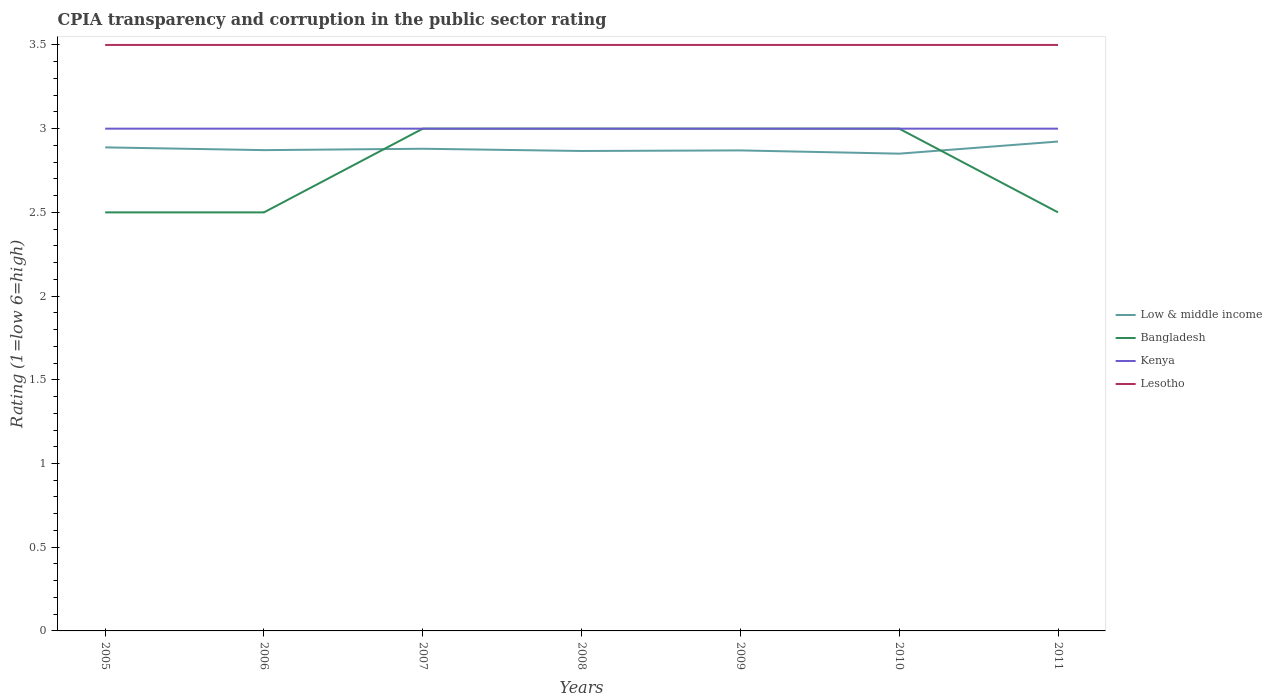How many different coloured lines are there?
Your answer should be very brief. 4. Is the number of lines equal to the number of legend labels?
Keep it short and to the point. Yes. Across all years, what is the maximum CPIA rating in Kenya?
Keep it short and to the point. 3. In which year was the CPIA rating in Bangladesh maximum?
Offer a very short reply. 2005. What is the difference between the highest and the second highest CPIA rating in Lesotho?
Offer a terse response. 0. What is the difference between the highest and the lowest CPIA rating in Lesotho?
Make the answer very short. 0. Is the CPIA rating in Kenya strictly greater than the CPIA rating in Bangladesh over the years?
Your response must be concise. No. Are the values on the major ticks of Y-axis written in scientific E-notation?
Offer a terse response. No. Does the graph contain any zero values?
Keep it short and to the point. No. How many legend labels are there?
Give a very brief answer. 4. How are the legend labels stacked?
Provide a short and direct response. Vertical. What is the title of the graph?
Your response must be concise. CPIA transparency and corruption in the public sector rating. Does "Mauritania" appear as one of the legend labels in the graph?
Ensure brevity in your answer.  No. What is the label or title of the X-axis?
Your response must be concise. Years. What is the label or title of the Y-axis?
Your answer should be compact. Rating (1=low 6=high). What is the Rating (1=low 6=high) in Low & middle income in 2005?
Ensure brevity in your answer.  2.89. What is the Rating (1=low 6=high) of Bangladesh in 2005?
Ensure brevity in your answer.  2.5. What is the Rating (1=low 6=high) of Lesotho in 2005?
Your response must be concise. 3.5. What is the Rating (1=low 6=high) of Low & middle income in 2006?
Keep it short and to the point. 2.87. What is the Rating (1=low 6=high) of Bangladesh in 2006?
Ensure brevity in your answer.  2.5. What is the Rating (1=low 6=high) in Kenya in 2006?
Offer a terse response. 3. What is the Rating (1=low 6=high) of Lesotho in 2006?
Offer a terse response. 3.5. What is the Rating (1=low 6=high) in Low & middle income in 2007?
Make the answer very short. 2.88. What is the Rating (1=low 6=high) in Bangladesh in 2007?
Your response must be concise. 3. What is the Rating (1=low 6=high) of Kenya in 2007?
Provide a succinct answer. 3. What is the Rating (1=low 6=high) in Lesotho in 2007?
Ensure brevity in your answer.  3.5. What is the Rating (1=low 6=high) in Low & middle income in 2008?
Provide a succinct answer. 2.87. What is the Rating (1=low 6=high) of Bangladesh in 2008?
Provide a succinct answer. 3. What is the Rating (1=low 6=high) of Lesotho in 2008?
Ensure brevity in your answer.  3.5. What is the Rating (1=low 6=high) in Low & middle income in 2009?
Your response must be concise. 2.87. What is the Rating (1=low 6=high) of Lesotho in 2009?
Your answer should be compact. 3.5. What is the Rating (1=low 6=high) of Low & middle income in 2010?
Your answer should be compact. 2.85. What is the Rating (1=low 6=high) of Bangladesh in 2010?
Provide a short and direct response. 3. What is the Rating (1=low 6=high) of Kenya in 2010?
Your answer should be very brief. 3. What is the Rating (1=low 6=high) in Lesotho in 2010?
Your answer should be compact. 3.5. What is the Rating (1=low 6=high) of Low & middle income in 2011?
Provide a short and direct response. 2.92. What is the Rating (1=low 6=high) of Kenya in 2011?
Ensure brevity in your answer.  3. What is the Rating (1=low 6=high) of Lesotho in 2011?
Provide a short and direct response. 3.5. Across all years, what is the maximum Rating (1=low 6=high) of Low & middle income?
Provide a short and direct response. 2.92. Across all years, what is the maximum Rating (1=low 6=high) in Lesotho?
Provide a succinct answer. 3.5. Across all years, what is the minimum Rating (1=low 6=high) of Low & middle income?
Your response must be concise. 2.85. Across all years, what is the minimum Rating (1=low 6=high) of Kenya?
Your answer should be very brief. 3. What is the total Rating (1=low 6=high) in Low & middle income in the graph?
Your answer should be very brief. 20.15. What is the total Rating (1=low 6=high) of Bangladesh in the graph?
Your answer should be compact. 19.5. What is the total Rating (1=low 6=high) in Kenya in the graph?
Ensure brevity in your answer.  21. What is the difference between the Rating (1=low 6=high) of Low & middle income in 2005 and that in 2006?
Provide a short and direct response. 0.02. What is the difference between the Rating (1=low 6=high) in Kenya in 2005 and that in 2006?
Provide a short and direct response. 0. What is the difference between the Rating (1=low 6=high) of Lesotho in 2005 and that in 2006?
Provide a short and direct response. 0. What is the difference between the Rating (1=low 6=high) of Low & middle income in 2005 and that in 2007?
Your answer should be very brief. 0.01. What is the difference between the Rating (1=low 6=high) of Low & middle income in 2005 and that in 2008?
Ensure brevity in your answer.  0.02. What is the difference between the Rating (1=low 6=high) of Bangladesh in 2005 and that in 2008?
Offer a very short reply. -0.5. What is the difference between the Rating (1=low 6=high) of Kenya in 2005 and that in 2008?
Give a very brief answer. 0. What is the difference between the Rating (1=low 6=high) in Lesotho in 2005 and that in 2008?
Provide a short and direct response. 0. What is the difference between the Rating (1=low 6=high) of Low & middle income in 2005 and that in 2009?
Provide a short and direct response. 0.02. What is the difference between the Rating (1=low 6=high) in Bangladesh in 2005 and that in 2009?
Offer a very short reply. -0.5. What is the difference between the Rating (1=low 6=high) of Lesotho in 2005 and that in 2009?
Your answer should be compact. 0. What is the difference between the Rating (1=low 6=high) of Low & middle income in 2005 and that in 2010?
Make the answer very short. 0.04. What is the difference between the Rating (1=low 6=high) in Bangladesh in 2005 and that in 2010?
Keep it short and to the point. -0.5. What is the difference between the Rating (1=low 6=high) of Kenya in 2005 and that in 2010?
Make the answer very short. 0. What is the difference between the Rating (1=low 6=high) of Low & middle income in 2005 and that in 2011?
Your answer should be very brief. -0.03. What is the difference between the Rating (1=low 6=high) of Bangladesh in 2005 and that in 2011?
Keep it short and to the point. 0. What is the difference between the Rating (1=low 6=high) in Lesotho in 2005 and that in 2011?
Your response must be concise. 0. What is the difference between the Rating (1=low 6=high) of Low & middle income in 2006 and that in 2007?
Make the answer very short. -0.01. What is the difference between the Rating (1=low 6=high) of Bangladesh in 2006 and that in 2007?
Offer a very short reply. -0.5. What is the difference between the Rating (1=low 6=high) in Lesotho in 2006 and that in 2007?
Keep it short and to the point. 0. What is the difference between the Rating (1=low 6=high) in Low & middle income in 2006 and that in 2008?
Your response must be concise. 0.01. What is the difference between the Rating (1=low 6=high) of Bangladesh in 2006 and that in 2008?
Provide a short and direct response. -0.5. What is the difference between the Rating (1=low 6=high) of Kenya in 2006 and that in 2008?
Provide a succinct answer. 0. What is the difference between the Rating (1=low 6=high) in Low & middle income in 2006 and that in 2009?
Offer a terse response. 0. What is the difference between the Rating (1=low 6=high) of Bangladesh in 2006 and that in 2009?
Your response must be concise. -0.5. What is the difference between the Rating (1=low 6=high) of Lesotho in 2006 and that in 2009?
Ensure brevity in your answer.  0. What is the difference between the Rating (1=low 6=high) in Low & middle income in 2006 and that in 2010?
Provide a short and direct response. 0.02. What is the difference between the Rating (1=low 6=high) of Kenya in 2006 and that in 2010?
Offer a terse response. 0. What is the difference between the Rating (1=low 6=high) in Low & middle income in 2006 and that in 2011?
Your answer should be compact. -0.05. What is the difference between the Rating (1=low 6=high) in Low & middle income in 2007 and that in 2008?
Provide a succinct answer. 0.01. What is the difference between the Rating (1=low 6=high) of Kenya in 2007 and that in 2008?
Offer a very short reply. 0. What is the difference between the Rating (1=low 6=high) of Lesotho in 2007 and that in 2008?
Your answer should be very brief. 0. What is the difference between the Rating (1=low 6=high) in Low & middle income in 2007 and that in 2009?
Ensure brevity in your answer.  0.01. What is the difference between the Rating (1=low 6=high) of Bangladesh in 2007 and that in 2009?
Your response must be concise. 0. What is the difference between the Rating (1=low 6=high) in Kenya in 2007 and that in 2009?
Provide a succinct answer. 0. What is the difference between the Rating (1=low 6=high) in Low & middle income in 2007 and that in 2010?
Provide a succinct answer. 0.03. What is the difference between the Rating (1=low 6=high) of Bangladesh in 2007 and that in 2010?
Give a very brief answer. 0. What is the difference between the Rating (1=low 6=high) in Lesotho in 2007 and that in 2010?
Your response must be concise. 0. What is the difference between the Rating (1=low 6=high) in Low & middle income in 2007 and that in 2011?
Ensure brevity in your answer.  -0.04. What is the difference between the Rating (1=low 6=high) of Kenya in 2007 and that in 2011?
Your answer should be very brief. 0. What is the difference between the Rating (1=low 6=high) of Low & middle income in 2008 and that in 2009?
Provide a succinct answer. -0. What is the difference between the Rating (1=low 6=high) of Bangladesh in 2008 and that in 2009?
Your answer should be very brief. 0. What is the difference between the Rating (1=low 6=high) of Kenya in 2008 and that in 2009?
Provide a succinct answer. 0. What is the difference between the Rating (1=low 6=high) in Lesotho in 2008 and that in 2009?
Keep it short and to the point. 0. What is the difference between the Rating (1=low 6=high) of Low & middle income in 2008 and that in 2010?
Provide a short and direct response. 0.02. What is the difference between the Rating (1=low 6=high) of Lesotho in 2008 and that in 2010?
Give a very brief answer. 0. What is the difference between the Rating (1=low 6=high) in Low & middle income in 2008 and that in 2011?
Provide a succinct answer. -0.06. What is the difference between the Rating (1=low 6=high) of Low & middle income in 2009 and that in 2010?
Ensure brevity in your answer.  0.02. What is the difference between the Rating (1=low 6=high) in Bangladesh in 2009 and that in 2010?
Offer a very short reply. 0. What is the difference between the Rating (1=low 6=high) in Low & middle income in 2009 and that in 2011?
Your answer should be very brief. -0.05. What is the difference between the Rating (1=low 6=high) in Bangladesh in 2009 and that in 2011?
Your response must be concise. 0.5. What is the difference between the Rating (1=low 6=high) of Lesotho in 2009 and that in 2011?
Your response must be concise. 0. What is the difference between the Rating (1=low 6=high) in Low & middle income in 2010 and that in 2011?
Ensure brevity in your answer.  -0.07. What is the difference between the Rating (1=low 6=high) of Bangladesh in 2010 and that in 2011?
Ensure brevity in your answer.  0.5. What is the difference between the Rating (1=low 6=high) in Low & middle income in 2005 and the Rating (1=low 6=high) in Bangladesh in 2006?
Give a very brief answer. 0.39. What is the difference between the Rating (1=low 6=high) of Low & middle income in 2005 and the Rating (1=low 6=high) of Kenya in 2006?
Give a very brief answer. -0.11. What is the difference between the Rating (1=low 6=high) of Low & middle income in 2005 and the Rating (1=low 6=high) of Lesotho in 2006?
Provide a short and direct response. -0.61. What is the difference between the Rating (1=low 6=high) in Bangladesh in 2005 and the Rating (1=low 6=high) in Lesotho in 2006?
Your response must be concise. -1. What is the difference between the Rating (1=low 6=high) of Low & middle income in 2005 and the Rating (1=low 6=high) of Bangladesh in 2007?
Make the answer very short. -0.11. What is the difference between the Rating (1=low 6=high) of Low & middle income in 2005 and the Rating (1=low 6=high) of Kenya in 2007?
Provide a succinct answer. -0.11. What is the difference between the Rating (1=low 6=high) of Low & middle income in 2005 and the Rating (1=low 6=high) of Lesotho in 2007?
Make the answer very short. -0.61. What is the difference between the Rating (1=low 6=high) in Bangladesh in 2005 and the Rating (1=low 6=high) in Lesotho in 2007?
Ensure brevity in your answer.  -1. What is the difference between the Rating (1=low 6=high) in Low & middle income in 2005 and the Rating (1=low 6=high) in Bangladesh in 2008?
Keep it short and to the point. -0.11. What is the difference between the Rating (1=low 6=high) of Low & middle income in 2005 and the Rating (1=low 6=high) of Kenya in 2008?
Your answer should be very brief. -0.11. What is the difference between the Rating (1=low 6=high) of Low & middle income in 2005 and the Rating (1=low 6=high) of Lesotho in 2008?
Ensure brevity in your answer.  -0.61. What is the difference between the Rating (1=low 6=high) in Kenya in 2005 and the Rating (1=low 6=high) in Lesotho in 2008?
Ensure brevity in your answer.  -0.5. What is the difference between the Rating (1=low 6=high) in Low & middle income in 2005 and the Rating (1=low 6=high) in Bangladesh in 2009?
Provide a short and direct response. -0.11. What is the difference between the Rating (1=low 6=high) of Low & middle income in 2005 and the Rating (1=low 6=high) of Kenya in 2009?
Provide a succinct answer. -0.11. What is the difference between the Rating (1=low 6=high) of Low & middle income in 2005 and the Rating (1=low 6=high) of Lesotho in 2009?
Provide a short and direct response. -0.61. What is the difference between the Rating (1=low 6=high) of Bangladesh in 2005 and the Rating (1=low 6=high) of Kenya in 2009?
Provide a short and direct response. -0.5. What is the difference between the Rating (1=low 6=high) in Bangladesh in 2005 and the Rating (1=low 6=high) in Lesotho in 2009?
Your answer should be very brief. -1. What is the difference between the Rating (1=low 6=high) in Low & middle income in 2005 and the Rating (1=low 6=high) in Bangladesh in 2010?
Provide a succinct answer. -0.11. What is the difference between the Rating (1=low 6=high) in Low & middle income in 2005 and the Rating (1=low 6=high) in Kenya in 2010?
Provide a short and direct response. -0.11. What is the difference between the Rating (1=low 6=high) of Low & middle income in 2005 and the Rating (1=low 6=high) of Lesotho in 2010?
Your answer should be compact. -0.61. What is the difference between the Rating (1=low 6=high) in Bangladesh in 2005 and the Rating (1=low 6=high) in Kenya in 2010?
Your response must be concise. -0.5. What is the difference between the Rating (1=low 6=high) of Low & middle income in 2005 and the Rating (1=low 6=high) of Bangladesh in 2011?
Offer a terse response. 0.39. What is the difference between the Rating (1=low 6=high) in Low & middle income in 2005 and the Rating (1=low 6=high) in Kenya in 2011?
Ensure brevity in your answer.  -0.11. What is the difference between the Rating (1=low 6=high) in Low & middle income in 2005 and the Rating (1=low 6=high) in Lesotho in 2011?
Provide a short and direct response. -0.61. What is the difference between the Rating (1=low 6=high) of Bangladesh in 2005 and the Rating (1=low 6=high) of Kenya in 2011?
Offer a very short reply. -0.5. What is the difference between the Rating (1=low 6=high) of Bangladesh in 2005 and the Rating (1=low 6=high) of Lesotho in 2011?
Ensure brevity in your answer.  -1. What is the difference between the Rating (1=low 6=high) of Low & middle income in 2006 and the Rating (1=low 6=high) of Bangladesh in 2007?
Your answer should be compact. -0.13. What is the difference between the Rating (1=low 6=high) in Low & middle income in 2006 and the Rating (1=low 6=high) in Kenya in 2007?
Offer a very short reply. -0.13. What is the difference between the Rating (1=low 6=high) in Low & middle income in 2006 and the Rating (1=low 6=high) in Lesotho in 2007?
Provide a short and direct response. -0.63. What is the difference between the Rating (1=low 6=high) in Bangladesh in 2006 and the Rating (1=low 6=high) in Kenya in 2007?
Offer a terse response. -0.5. What is the difference between the Rating (1=low 6=high) in Low & middle income in 2006 and the Rating (1=low 6=high) in Bangladesh in 2008?
Your answer should be very brief. -0.13. What is the difference between the Rating (1=low 6=high) in Low & middle income in 2006 and the Rating (1=low 6=high) in Kenya in 2008?
Provide a succinct answer. -0.13. What is the difference between the Rating (1=low 6=high) of Low & middle income in 2006 and the Rating (1=low 6=high) of Lesotho in 2008?
Give a very brief answer. -0.63. What is the difference between the Rating (1=low 6=high) in Low & middle income in 2006 and the Rating (1=low 6=high) in Bangladesh in 2009?
Make the answer very short. -0.13. What is the difference between the Rating (1=low 6=high) of Low & middle income in 2006 and the Rating (1=low 6=high) of Kenya in 2009?
Give a very brief answer. -0.13. What is the difference between the Rating (1=low 6=high) of Low & middle income in 2006 and the Rating (1=low 6=high) of Lesotho in 2009?
Provide a succinct answer. -0.63. What is the difference between the Rating (1=low 6=high) of Bangladesh in 2006 and the Rating (1=low 6=high) of Kenya in 2009?
Offer a very short reply. -0.5. What is the difference between the Rating (1=low 6=high) in Bangladesh in 2006 and the Rating (1=low 6=high) in Lesotho in 2009?
Offer a very short reply. -1. What is the difference between the Rating (1=low 6=high) in Kenya in 2006 and the Rating (1=low 6=high) in Lesotho in 2009?
Your answer should be very brief. -0.5. What is the difference between the Rating (1=low 6=high) of Low & middle income in 2006 and the Rating (1=low 6=high) of Bangladesh in 2010?
Your answer should be very brief. -0.13. What is the difference between the Rating (1=low 6=high) of Low & middle income in 2006 and the Rating (1=low 6=high) of Kenya in 2010?
Provide a short and direct response. -0.13. What is the difference between the Rating (1=low 6=high) of Low & middle income in 2006 and the Rating (1=low 6=high) of Lesotho in 2010?
Make the answer very short. -0.63. What is the difference between the Rating (1=low 6=high) in Bangladesh in 2006 and the Rating (1=low 6=high) in Lesotho in 2010?
Provide a short and direct response. -1. What is the difference between the Rating (1=low 6=high) in Kenya in 2006 and the Rating (1=low 6=high) in Lesotho in 2010?
Offer a very short reply. -0.5. What is the difference between the Rating (1=low 6=high) of Low & middle income in 2006 and the Rating (1=low 6=high) of Bangladesh in 2011?
Keep it short and to the point. 0.37. What is the difference between the Rating (1=low 6=high) of Low & middle income in 2006 and the Rating (1=low 6=high) of Kenya in 2011?
Ensure brevity in your answer.  -0.13. What is the difference between the Rating (1=low 6=high) of Low & middle income in 2006 and the Rating (1=low 6=high) of Lesotho in 2011?
Provide a short and direct response. -0.63. What is the difference between the Rating (1=low 6=high) in Kenya in 2006 and the Rating (1=low 6=high) in Lesotho in 2011?
Give a very brief answer. -0.5. What is the difference between the Rating (1=low 6=high) of Low & middle income in 2007 and the Rating (1=low 6=high) of Bangladesh in 2008?
Provide a short and direct response. -0.12. What is the difference between the Rating (1=low 6=high) in Low & middle income in 2007 and the Rating (1=low 6=high) in Kenya in 2008?
Offer a very short reply. -0.12. What is the difference between the Rating (1=low 6=high) of Low & middle income in 2007 and the Rating (1=low 6=high) of Lesotho in 2008?
Make the answer very short. -0.62. What is the difference between the Rating (1=low 6=high) of Bangladesh in 2007 and the Rating (1=low 6=high) of Kenya in 2008?
Provide a succinct answer. 0. What is the difference between the Rating (1=low 6=high) in Kenya in 2007 and the Rating (1=low 6=high) in Lesotho in 2008?
Offer a terse response. -0.5. What is the difference between the Rating (1=low 6=high) in Low & middle income in 2007 and the Rating (1=low 6=high) in Bangladesh in 2009?
Your response must be concise. -0.12. What is the difference between the Rating (1=low 6=high) of Low & middle income in 2007 and the Rating (1=low 6=high) of Kenya in 2009?
Keep it short and to the point. -0.12. What is the difference between the Rating (1=low 6=high) of Low & middle income in 2007 and the Rating (1=low 6=high) of Lesotho in 2009?
Offer a very short reply. -0.62. What is the difference between the Rating (1=low 6=high) of Bangladesh in 2007 and the Rating (1=low 6=high) of Kenya in 2009?
Make the answer very short. 0. What is the difference between the Rating (1=low 6=high) in Bangladesh in 2007 and the Rating (1=low 6=high) in Lesotho in 2009?
Offer a very short reply. -0.5. What is the difference between the Rating (1=low 6=high) in Kenya in 2007 and the Rating (1=low 6=high) in Lesotho in 2009?
Your response must be concise. -0.5. What is the difference between the Rating (1=low 6=high) of Low & middle income in 2007 and the Rating (1=low 6=high) of Bangladesh in 2010?
Give a very brief answer. -0.12. What is the difference between the Rating (1=low 6=high) of Low & middle income in 2007 and the Rating (1=low 6=high) of Kenya in 2010?
Keep it short and to the point. -0.12. What is the difference between the Rating (1=low 6=high) of Low & middle income in 2007 and the Rating (1=low 6=high) of Lesotho in 2010?
Your response must be concise. -0.62. What is the difference between the Rating (1=low 6=high) of Bangladesh in 2007 and the Rating (1=low 6=high) of Kenya in 2010?
Keep it short and to the point. 0. What is the difference between the Rating (1=low 6=high) of Kenya in 2007 and the Rating (1=low 6=high) of Lesotho in 2010?
Your answer should be very brief. -0.5. What is the difference between the Rating (1=low 6=high) in Low & middle income in 2007 and the Rating (1=low 6=high) in Bangladesh in 2011?
Give a very brief answer. 0.38. What is the difference between the Rating (1=low 6=high) of Low & middle income in 2007 and the Rating (1=low 6=high) of Kenya in 2011?
Offer a terse response. -0.12. What is the difference between the Rating (1=low 6=high) in Low & middle income in 2007 and the Rating (1=low 6=high) in Lesotho in 2011?
Offer a terse response. -0.62. What is the difference between the Rating (1=low 6=high) in Bangladesh in 2007 and the Rating (1=low 6=high) in Kenya in 2011?
Keep it short and to the point. 0. What is the difference between the Rating (1=low 6=high) of Low & middle income in 2008 and the Rating (1=low 6=high) of Bangladesh in 2009?
Make the answer very short. -0.13. What is the difference between the Rating (1=low 6=high) of Low & middle income in 2008 and the Rating (1=low 6=high) of Kenya in 2009?
Offer a terse response. -0.13. What is the difference between the Rating (1=low 6=high) in Low & middle income in 2008 and the Rating (1=low 6=high) in Lesotho in 2009?
Provide a succinct answer. -0.63. What is the difference between the Rating (1=low 6=high) of Bangladesh in 2008 and the Rating (1=low 6=high) of Lesotho in 2009?
Your response must be concise. -0.5. What is the difference between the Rating (1=low 6=high) in Low & middle income in 2008 and the Rating (1=low 6=high) in Bangladesh in 2010?
Your answer should be very brief. -0.13. What is the difference between the Rating (1=low 6=high) of Low & middle income in 2008 and the Rating (1=low 6=high) of Kenya in 2010?
Offer a very short reply. -0.13. What is the difference between the Rating (1=low 6=high) of Low & middle income in 2008 and the Rating (1=low 6=high) of Lesotho in 2010?
Provide a short and direct response. -0.63. What is the difference between the Rating (1=low 6=high) in Bangladesh in 2008 and the Rating (1=low 6=high) in Kenya in 2010?
Provide a succinct answer. 0. What is the difference between the Rating (1=low 6=high) of Kenya in 2008 and the Rating (1=low 6=high) of Lesotho in 2010?
Make the answer very short. -0.5. What is the difference between the Rating (1=low 6=high) in Low & middle income in 2008 and the Rating (1=low 6=high) in Bangladesh in 2011?
Ensure brevity in your answer.  0.37. What is the difference between the Rating (1=low 6=high) in Low & middle income in 2008 and the Rating (1=low 6=high) in Kenya in 2011?
Offer a very short reply. -0.13. What is the difference between the Rating (1=low 6=high) of Low & middle income in 2008 and the Rating (1=low 6=high) of Lesotho in 2011?
Your response must be concise. -0.63. What is the difference between the Rating (1=low 6=high) in Bangladesh in 2008 and the Rating (1=low 6=high) in Kenya in 2011?
Offer a terse response. 0. What is the difference between the Rating (1=low 6=high) in Low & middle income in 2009 and the Rating (1=low 6=high) in Bangladesh in 2010?
Give a very brief answer. -0.13. What is the difference between the Rating (1=low 6=high) of Low & middle income in 2009 and the Rating (1=low 6=high) of Kenya in 2010?
Your answer should be very brief. -0.13. What is the difference between the Rating (1=low 6=high) of Low & middle income in 2009 and the Rating (1=low 6=high) of Lesotho in 2010?
Keep it short and to the point. -0.63. What is the difference between the Rating (1=low 6=high) of Bangladesh in 2009 and the Rating (1=low 6=high) of Kenya in 2010?
Your response must be concise. 0. What is the difference between the Rating (1=low 6=high) of Kenya in 2009 and the Rating (1=low 6=high) of Lesotho in 2010?
Your answer should be very brief. -0.5. What is the difference between the Rating (1=low 6=high) in Low & middle income in 2009 and the Rating (1=low 6=high) in Bangladesh in 2011?
Provide a succinct answer. 0.37. What is the difference between the Rating (1=low 6=high) of Low & middle income in 2009 and the Rating (1=low 6=high) of Kenya in 2011?
Offer a very short reply. -0.13. What is the difference between the Rating (1=low 6=high) of Low & middle income in 2009 and the Rating (1=low 6=high) of Lesotho in 2011?
Your response must be concise. -0.63. What is the difference between the Rating (1=low 6=high) in Bangladesh in 2009 and the Rating (1=low 6=high) in Kenya in 2011?
Your answer should be very brief. 0. What is the difference between the Rating (1=low 6=high) of Kenya in 2009 and the Rating (1=low 6=high) of Lesotho in 2011?
Your response must be concise. -0.5. What is the difference between the Rating (1=low 6=high) of Low & middle income in 2010 and the Rating (1=low 6=high) of Bangladesh in 2011?
Your answer should be very brief. 0.35. What is the difference between the Rating (1=low 6=high) of Low & middle income in 2010 and the Rating (1=low 6=high) of Kenya in 2011?
Give a very brief answer. -0.15. What is the difference between the Rating (1=low 6=high) in Low & middle income in 2010 and the Rating (1=low 6=high) in Lesotho in 2011?
Your answer should be very brief. -0.65. What is the difference between the Rating (1=low 6=high) in Bangladesh in 2010 and the Rating (1=low 6=high) in Kenya in 2011?
Your answer should be compact. 0. What is the difference between the Rating (1=low 6=high) of Bangladesh in 2010 and the Rating (1=low 6=high) of Lesotho in 2011?
Your answer should be very brief. -0.5. What is the difference between the Rating (1=low 6=high) in Kenya in 2010 and the Rating (1=low 6=high) in Lesotho in 2011?
Your answer should be very brief. -0.5. What is the average Rating (1=low 6=high) of Low & middle income per year?
Offer a very short reply. 2.88. What is the average Rating (1=low 6=high) of Bangladesh per year?
Keep it short and to the point. 2.79. In the year 2005, what is the difference between the Rating (1=low 6=high) of Low & middle income and Rating (1=low 6=high) of Bangladesh?
Give a very brief answer. 0.39. In the year 2005, what is the difference between the Rating (1=low 6=high) in Low & middle income and Rating (1=low 6=high) in Kenya?
Keep it short and to the point. -0.11. In the year 2005, what is the difference between the Rating (1=low 6=high) in Low & middle income and Rating (1=low 6=high) in Lesotho?
Keep it short and to the point. -0.61. In the year 2005, what is the difference between the Rating (1=low 6=high) in Kenya and Rating (1=low 6=high) in Lesotho?
Offer a terse response. -0.5. In the year 2006, what is the difference between the Rating (1=low 6=high) in Low & middle income and Rating (1=low 6=high) in Bangladesh?
Provide a short and direct response. 0.37. In the year 2006, what is the difference between the Rating (1=low 6=high) of Low & middle income and Rating (1=low 6=high) of Kenya?
Give a very brief answer. -0.13. In the year 2006, what is the difference between the Rating (1=low 6=high) in Low & middle income and Rating (1=low 6=high) in Lesotho?
Offer a terse response. -0.63. In the year 2006, what is the difference between the Rating (1=low 6=high) in Bangladesh and Rating (1=low 6=high) in Lesotho?
Give a very brief answer. -1. In the year 2006, what is the difference between the Rating (1=low 6=high) of Kenya and Rating (1=low 6=high) of Lesotho?
Your answer should be compact. -0.5. In the year 2007, what is the difference between the Rating (1=low 6=high) in Low & middle income and Rating (1=low 6=high) in Bangladesh?
Provide a succinct answer. -0.12. In the year 2007, what is the difference between the Rating (1=low 6=high) of Low & middle income and Rating (1=low 6=high) of Kenya?
Offer a very short reply. -0.12. In the year 2007, what is the difference between the Rating (1=low 6=high) in Low & middle income and Rating (1=low 6=high) in Lesotho?
Your answer should be very brief. -0.62. In the year 2007, what is the difference between the Rating (1=low 6=high) in Bangladesh and Rating (1=low 6=high) in Kenya?
Keep it short and to the point. 0. In the year 2007, what is the difference between the Rating (1=low 6=high) in Bangladesh and Rating (1=low 6=high) in Lesotho?
Provide a succinct answer. -0.5. In the year 2008, what is the difference between the Rating (1=low 6=high) of Low & middle income and Rating (1=low 6=high) of Bangladesh?
Provide a short and direct response. -0.13. In the year 2008, what is the difference between the Rating (1=low 6=high) in Low & middle income and Rating (1=low 6=high) in Kenya?
Provide a succinct answer. -0.13. In the year 2008, what is the difference between the Rating (1=low 6=high) in Low & middle income and Rating (1=low 6=high) in Lesotho?
Your answer should be very brief. -0.63. In the year 2008, what is the difference between the Rating (1=low 6=high) of Bangladesh and Rating (1=low 6=high) of Kenya?
Your answer should be very brief. 0. In the year 2009, what is the difference between the Rating (1=low 6=high) in Low & middle income and Rating (1=low 6=high) in Bangladesh?
Keep it short and to the point. -0.13. In the year 2009, what is the difference between the Rating (1=low 6=high) in Low & middle income and Rating (1=low 6=high) in Kenya?
Provide a short and direct response. -0.13. In the year 2009, what is the difference between the Rating (1=low 6=high) in Low & middle income and Rating (1=low 6=high) in Lesotho?
Give a very brief answer. -0.63. In the year 2009, what is the difference between the Rating (1=low 6=high) of Bangladesh and Rating (1=low 6=high) of Kenya?
Give a very brief answer. 0. In the year 2009, what is the difference between the Rating (1=low 6=high) in Bangladesh and Rating (1=low 6=high) in Lesotho?
Provide a short and direct response. -0.5. In the year 2009, what is the difference between the Rating (1=low 6=high) of Kenya and Rating (1=low 6=high) of Lesotho?
Your answer should be very brief. -0.5. In the year 2010, what is the difference between the Rating (1=low 6=high) of Low & middle income and Rating (1=low 6=high) of Bangladesh?
Your answer should be very brief. -0.15. In the year 2010, what is the difference between the Rating (1=low 6=high) of Low & middle income and Rating (1=low 6=high) of Kenya?
Your answer should be very brief. -0.15. In the year 2010, what is the difference between the Rating (1=low 6=high) in Low & middle income and Rating (1=low 6=high) in Lesotho?
Your answer should be very brief. -0.65. In the year 2010, what is the difference between the Rating (1=low 6=high) in Bangladesh and Rating (1=low 6=high) in Kenya?
Provide a succinct answer. 0. In the year 2010, what is the difference between the Rating (1=low 6=high) in Kenya and Rating (1=low 6=high) in Lesotho?
Your response must be concise. -0.5. In the year 2011, what is the difference between the Rating (1=low 6=high) in Low & middle income and Rating (1=low 6=high) in Bangladesh?
Provide a short and direct response. 0.42. In the year 2011, what is the difference between the Rating (1=low 6=high) in Low & middle income and Rating (1=low 6=high) in Kenya?
Your answer should be compact. -0.08. In the year 2011, what is the difference between the Rating (1=low 6=high) in Low & middle income and Rating (1=low 6=high) in Lesotho?
Your answer should be compact. -0.58. In the year 2011, what is the difference between the Rating (1=low 6=high) of Bangladesh and Rating (1=low 6=high) of Kenya?
Give a very brief answer. -0.5. In the year 2011, what is the difference between the Rating (1=low 6=high) in Bangladesh and Rating (1=low 6=high) in Lesotho?
Provide a short and direct response. -1. What is the ratio of the Rating (1=low 6=high) in Kenya in 2005 to that in 2006?
Your response must be concise. 1. What is the ratio of the Rating (1=low 6=high) of Lesotho in 2005 to that in 2006?
Provide a succinct answer. 1. What is the ratio of the Rating (1=low 6=high) in Low & middle income in 2005 to that in 2007?
Ensure brevity in your answer.  1. What is the ratio of the Rating (1=low 6=high) of Kenya in 2005 to that in 2007?
Your answer should be very brief. 1. What is the ratio of the Rating (1=low 6=high) in Lesotho in 2005 to that in 2007?
Your answer should be very brief. 1. What is the ratio of the Rating (1=low 6=high) of Low & middle income in 2005 to that in 2008?
Provide a short and direct response. 1.01. What is the ratio of the Rating (1=low 6=high) in Kenya in 2005 to that in 2008?
Ensure brevity in your answer.  1. What is the ratio of the Rating (1=low 6=high) in Lesotho in 2005 to that in 2008?
Your answer should be very brief. 1. What is the ratio of the Rating (1=low 6=high) in Low & middle income in 2005 to that in 2009?
Ensure brevity in your answer.  1.01. What is the ratio of the Rating (1=low 6=high) of Lesotho in 2005 to that in 2009?
Give a very brief answer. 1. What is the ratio of the Rating (1=low 6=high) of Low & middle income in 2005 to that in 2010?
Provide a short and direct response. 1.01. What is the ratio of the Rating (1=low 6=high) in Lesotho in 2005 to that in 2010?
Give a very brief answer. 1. What is the ratio of the Rating (1=low 6=high) in Low & middle income in 2005 to that in 2011?
Provide a short and direct response. 0.99. What is the ratio of the Rating (1=low 6=high) of Bangladesh in 2005 to that in 2011?
Your response must be concise. 1. What is the ratio of the Rating (1=low 6=high) in Kenya in 2005 to that in 2011?
Your answer should be very brief. 1. What is the ratio of the Rating (1=low 6=high) of Low & middle income in 2006 to that in 2007?
Your response must be concise. 1. What is the ratio of the Rating (1=low 6=high) of Kenya in 2006 to that in 2007?
Make the answer very short. 1. What is the ratio of the Rating (1=low 6=high) of Lesotho in 2006 to that in 2007?
Your answer should be very brief. 1. What is the ratio of the Rating (1=low 6=high) of Low & middle income in 2006 to that in 2008?
Give a very brief answer. 1. What is the ratio of the Rating (1=low 6=high) in Kenya in 2006 to that in 2008?
Keep it short and to the point. 1. What is the ratio of the Rating (1=low 6=high) in Bangladesh in 2006 to that in 2009?
Provide a short and direct response. 0.83. What is the ratio of the Rating (1=low 6=high) in Low & middle income in 2006 to that in 2010?
Provide a short and direct response. 1.01. What is the ratio of the Rating (1=low 6=high) of Bangladesh in 2006 to that in 2010?
Offer a terse response. 0.83. What is the ratio of the Rating (1=low 6=high) in Low & middle income in 2006 to that in 2011?
Provide a short and direct response. 0.98. What is the ratio of the Rating (1=low 6=high) of Bangladesh in 2006 to that in 2011?
Your answer should be compact. 1. What is the ratio of the Rating (1=low 6=high) in Low & middle income in 2007 to that in 2008?
Offer a terse response. 1. What is the ratio of the Rating (1=low 6=high) in Bangladesh in 2007 to that in 2008?
Your response must be concise. 1. What is the ratio of the Rating (1=low 6=high) of Lesotho in 2007 to that in 2008?
Your response must be concise. 1. What is the ratio of the Rating (1=low 6=high) of Low & middle income in 2007 to that in 2009?
Your answer should be very brief. 1. What is the ratio of the Rating (1=low 6=high) of Bangladesh in 2007 to that in 2009?
Your response must be concise. 1. What is the ratio of the Rating (1=low 6=high) of Lesotho in 2007 to that in 2009?
Keep it short and to the point. 1. What is the ratio of the Rating (1=low 6=high) of Low & middle income in 2007 to that in 2010?
Make the answer very short. 1.01. What is the ratio of the Rating (1=low 6=high) of Bangladesh in 2007 to that in 2010?
Provide a short and direct response. 1. What is the ratio of the Rating (1=low 6=high) in Kenya in 2007 to that in 2010?
Give a very brief answer. 1. What is the ratio of the Rating (1=low 6=high) in Lesotho in 2007 to that in 2010?
Give a very brief answer. 1. What is the ratio of the Rating (1=low 6=high) in Low & middle income in 2007 to that in 2011?
Your response must be concise. 0.99. What is the ratio of the Rating (1=low 6=high) of Low & middle income in 2008 to that in 2009?
Your response must be concise. 1. What is the ratio of the Rating (1=low 6=high) of Kenya in 2008 to that in 2009?
Keep it short and to the point. 1. What is the ratio of the Rating (1=low 6=high) in Low & middle income in 2008 to that in 2010?
Provide a short and direct response. 1.01. What is the ratio of the Rating (1=low 6=high) in Bangladesh in 2008 to that in 2010?
Your answer should be very brief. 1. What is the ratio of the Rating (1=low 6=high) of Kenya in 2008 to that in 2010?
Make the answer very short. 1. What is the ratio of the Rating (1=low 6=high) of Lesotho in 2008 to that in 2010?
Make the answer very short. 1. What is the ratio of the Rating (1=low 6=high) of Low & middle income in 2008 to that in 2011?
Provide a short and direct response. 0.98. What is the ratio of the Rating (1=low 6=high) in Kenya in 2008 to that in 2011?
Your answer should be compact. 1. What is the ratio of the Rating (1=low 6=high) of Low & middle income in 2009 to that in 2010?
Offer a very short reply. 1.01. What is the ratio of the Rating (1=low 6=high) of Kenya in 2009 to that in 2010?
Provide a short and direct response. 1. What is the ratio of the Rating (1=low 6=high) in Lesotho in 2009 to that in 2010?
Give a very brief answer. 1. What is the ratio of the Rating (1=low 6=high) in Low & middle income in 2009 to that in 2011?
Provide a succinct answer. 0.98. What is the ratio of the Rating (1=low 6=high) in Kenya in 2009 to that in 2011?
Provide a succinct answer. 1. What is the ratio of the Rating (1=low 6=high) in Lesotho in 2009 to that in 2011?
Make the answer very short. 1. What is the ratio of the Rating (1=low 6=high) of Low & middle income in 2010 to that in 2011?
Make the answer very short. 0.98. What is the difference between the highest and the second highest Rating (1=low 6=high) in Low & middle income?
Make the answer very short. 0.03. What is the difference between the highest and the second highest Rating (1=low 6=high) of Bangladesh?
Ensure brevity in your answer.  0. What is the difference between the highest and the lowest Rating (1=low 6=high) in Low & middle income?
Your answer should be very brief. 0.07. What is the difference between the highest and the lowest Rating (1=low 6=high) in Bangladesh?
Make the answer very short. 0.5. 